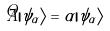Convert formula to latex. <formula><loc_0><loc_0><loc_500><loc_500>\hat { A } | \psi _ { \alpha } \rangle = \alpha | \psi _ { \alpha } \rangle</formula> 